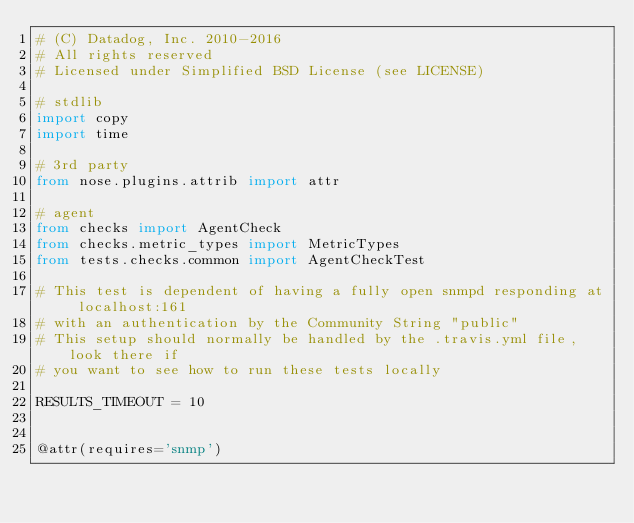Convert code to text. <code><loc_0><loc_0><loc_500><loc_500><_Python_># (C) Datadog, Inc. 2010-2016
# All rights reserved
# Licensed under Simplified BSD License (see LICENSE)

# stdlib
import copy
import time

# 3rd party
from nose.plugins.attrib import attr

# agent
from checks import AgentCheck
from checks.metric_types import MetricTypes
from tests.checks.common import AgentCheckTest

# This test is dependent of having a fully open snmpd responding at localhost:161
# with an authentication by the Community String "public"
# This setup should normally be handled by the .travis.yml file, look there if
# you want to see how to run these tests locally

RESULTS_TIMEOUT = 10


@attr(requires='snmp')</code> 